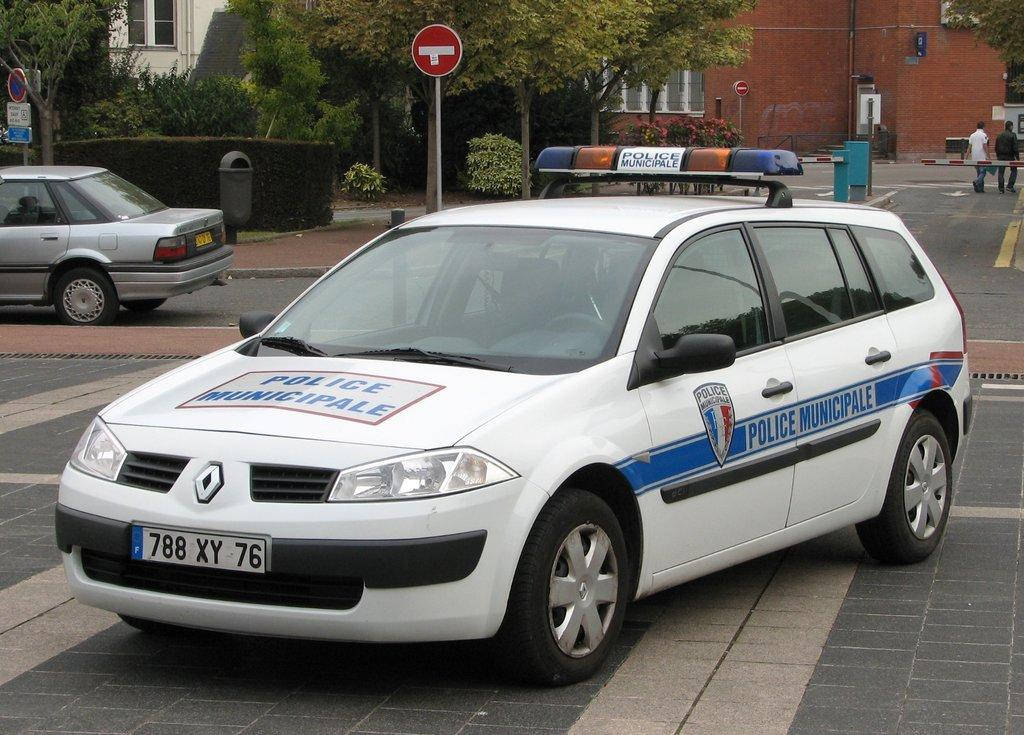What types of vehicles can be seen on the road in the image? There are motor vehicles on the road in the image. What are the people in the image doing? There are persons walking on the road in the image. What structures are present to control traffic or access in the image? Barricades are present in the image. What can be used for disposing of waste in the image? Trash bins are visible in the image. What can be seen providing information or instructions in the image? Sign boards are present in the image. What type of vegetation is present in the image? Trees are present in the image. What type of structures are visible in the image? Buildings are visible in the image. What other type of vegetation is present in the image? Bushes are present in the image. Where is the cobweb located in the image? There is no cobweb present in the image. 